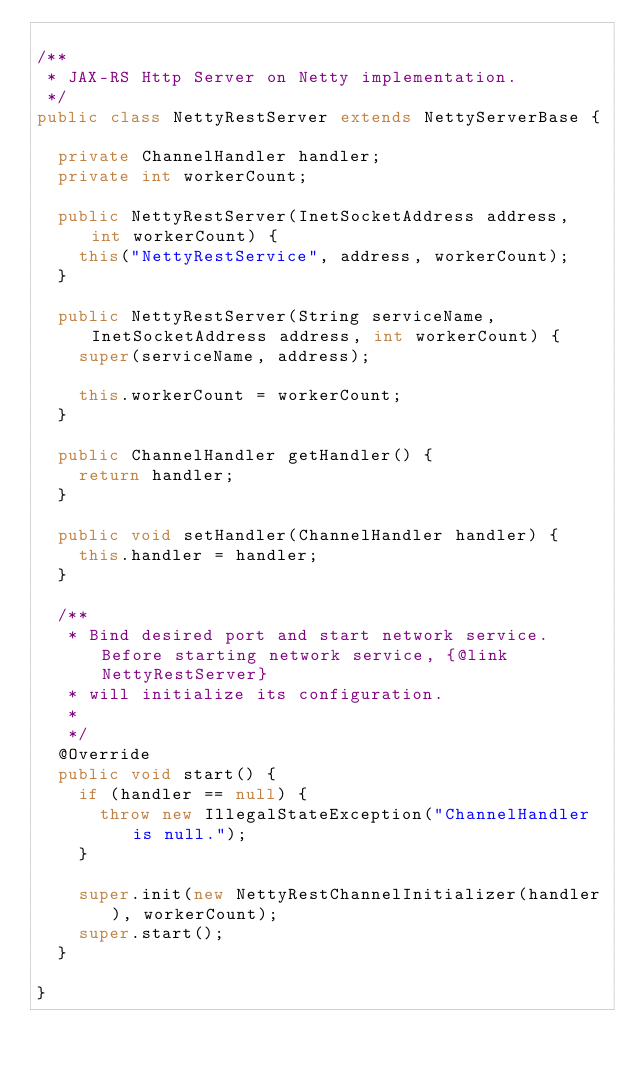<code> <loc_0><loc_0><loc_500><loc_500><_Java_>
/**
 * JAX-RS Http Server on Netty implementation.
 */
public class NettyRestServer extends NettyServerBase {
  
  private ChannelHandler handler;
  private int workerCount;

  public NettyRestServer(InetSocketAddress address, int workerCount) {
    this("NettyRestService", address, workerCount);
  }

  public NettyRestServer(String serviceName, InetSocketAddress address, int workerCount) {
    super(serviceName, address);
    
    this.workerCount = workerCount;
  }

  public ChannelHandler getHandler() {
    return handler;
  }

  public void setHandler(ChannelHandler handler) {
    this.handler = handler;
  }

  /**
   * Bind desired port and start network service. Before starting network service, {@link NettyRestServer}
   * will initialize its configuration.
   * 
   */
  @Override
  public void start() {
    if (handler == null) {
      throw new IllegalStateException("ChannelHandler is null.");
    }
    
    super.init(new NettyRestChannelInitializer(handler), workerCount);
    super.start();
  }

}
</code> 